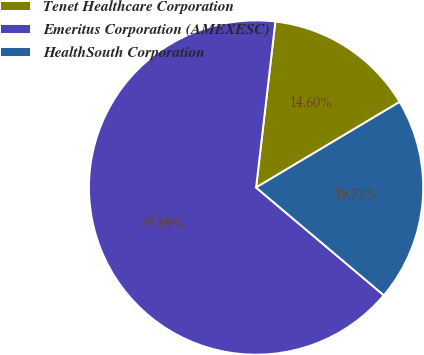Convert chart to OTSL. <chart><loc_0><loc_0><loc_500><loc_500><pie_chart><fcel>Tenet Healthcare Corporation<fcel>Emeritus Corporation (AMEXESC)<fcel>HealthSouth Corporation<nl><fcel>14.6%<fcel>65.69%<fcel>19.71%<nl></chart> 